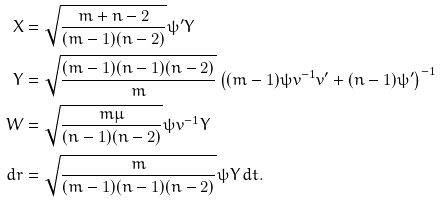Convert formula to latex. <formula><loc_0><loc_0><loc_500><loc_500>X & = \sqrt { \frac { m + n - 2 } { ( m - 1 ) ( n - 2 ) } } \psi ^ { \prime } Y \\ Y & = \sqrt { \frac { ( m - 1 ) ( n - 1 ) ( n - 2 ) } { m } } \left ( ( m - 1 ) \psi v ^ { - 1 } v ^ { \prime } + ( n - 1 ) \psi ^ { \prime } \right ) ^ { - 1 } \\ W & = \sqrt { \frac { m \mu } { ( n - 1 ) ( n - 2 ) } } \psi v ^ { - 1 } Y \\ d r & = \sqrt { \frac { m } { ( m - 1 ) ( n - 1 ) ( n - 2 ) } } \psi Y \, d t .</formula> 